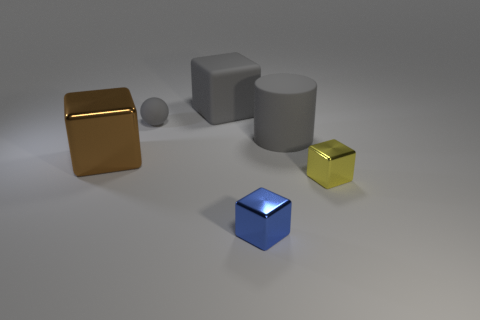Subtract all blue metallic cubes. How many cubes are left? 3 Add 3 small objects. How many objects exist? 9 Subtract all yellow cubes. How many cubes are left? 3 Subtract all red blocks. Subtract all gray spheres. How many blocks are left? 4 Subtract all cylinders. How many objects are left? 5 Subtract all metallic objects. Subtract all brown rubber things. How many objects are left? 3 Add 3 brown blocks. How many brown blocks are left? 4 Add 6 large red things. How many large red things exist? 6 Subtract 0 yellow cylinders. How many objects are left? 6 